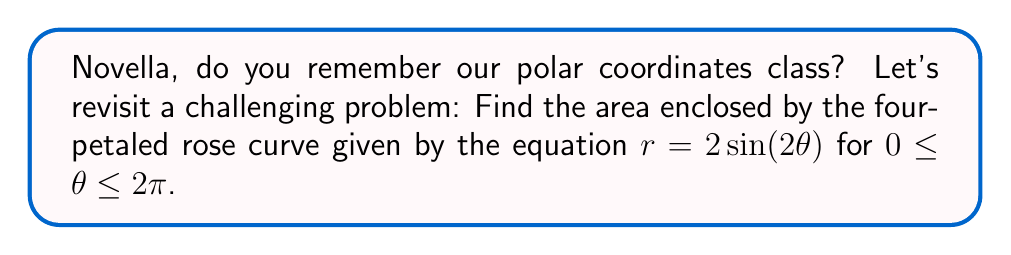What is the answer to this math problem? To find the area enclosed by the polar rose curve, we'll follow these steps:

1) The general formula for the area enclosed by a polar curve is:

   $$A = \frac{1}{2} \int_{0}^{2\pi} r^2 d\theta$$

2) In this case, $r = 2\sin(2\theta)$, so we need to square this:

   $$r^2 = 4\sin^2(2\theta)$$

3) Substituting this into our area formula:

   $$A = \frac{1}{2} \int_{0}^{2\pi} 4\sin^2(2\theta) d\theta$$

4) Simplify:

   $$A = 2 \int_{0}^{2\pi} \sin^2(2\theta) d\theta$$

5) We can use the trigonometric identity $\sin^2(x) = \frac{1 - \cos(2x)}{2}$:

   $$A = 2 \int_{0}^{2\pi} \frac{1 - \cos(4\theta)}{2} d\theta$$

6) Simplify:

   $$A = \int_{0}^{2\pi} (1 - \cos(4\theta)) d\theta$$

7) Integrate:

   $$A = [\theta - \frac{1}{4}\sin(4\theta)]_{0}^{2\pi}$$

8) Evaluate the integral:

   $$A = (2\pi - 0) - (\frac{1}{4}\sin(8\pi) - \frac{1}{4}\sin(0))$$

9) Simplify, noting that $\sin(8\pi) = \sin(0) = 0$:

   $$A = 2\pi - 0 = 2\pi$$

Therefore, the area enclosed by the four-petaled rose curve is $2\pi$ square units.

[asy]
import graph;
size(200);
real r(real t) {return 2*sin(2*t);}
path g=polargraph(r,0,2*pi,300);
draw(g,blue);
xaxis(arrow=Arrow);
yaxis(arrow=Arrow);
label("$x$",(1.2,0),E);
label("$y$",(0,1.2),N);
[/asy]
Answer: $2\pi$ square units 